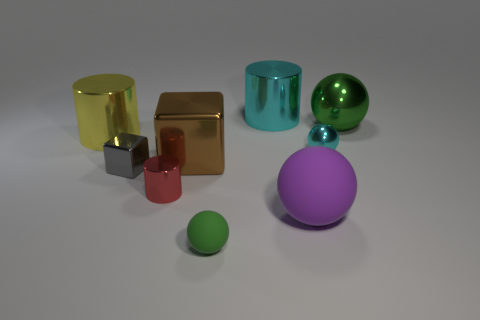Add 1 small blocks. How many objects exist? 10 Subtract all spheres. How many objects are left? 5 Add 5 green metallic objects. How many green metallic objects are left? 6 Add 7 cyan metal cylinders. How many cyan metal cylinders exist? 8 Subtract 0 cyan blocks. How many objects are left? 9 Subtract all purple cubes. Subtract all big shiny cylinders. How many objects are left? 7 